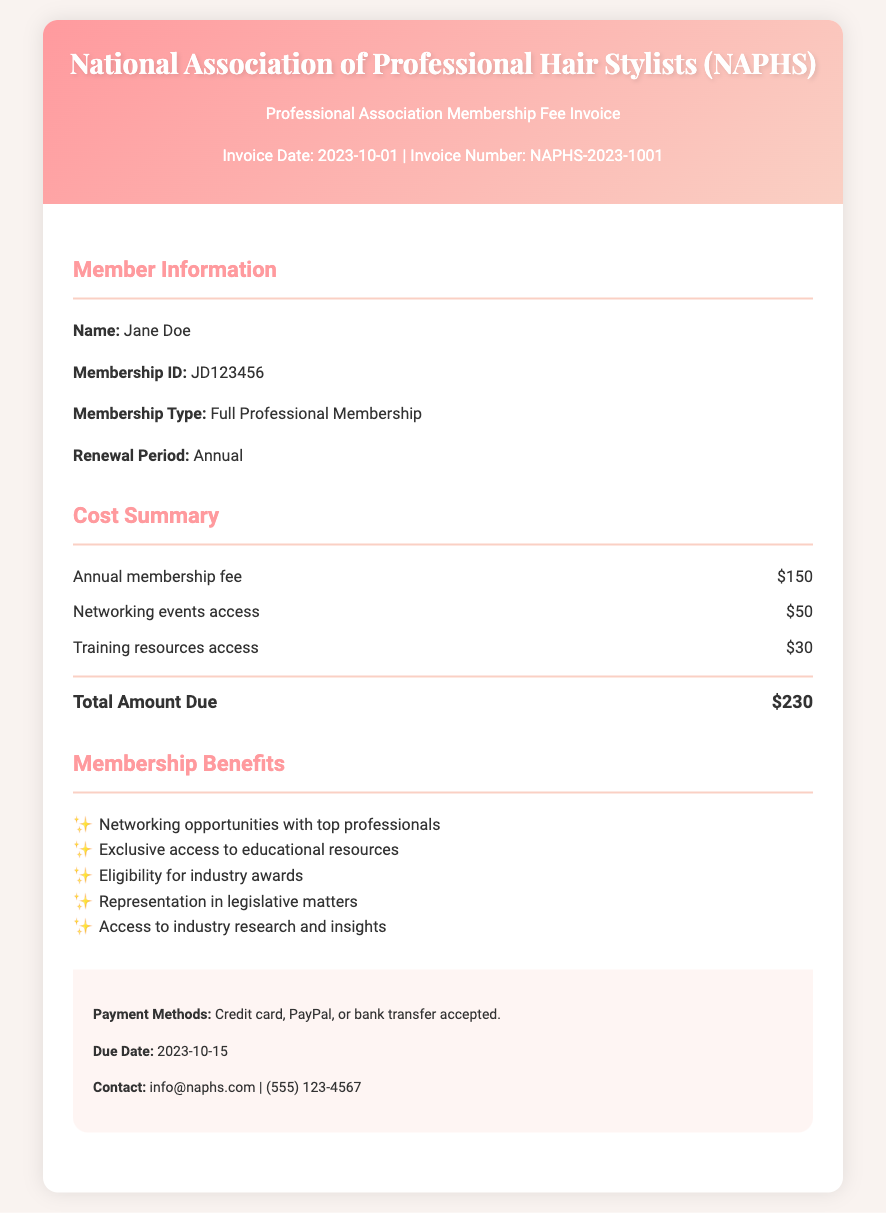What is the name of the membership organization? The document specifies that the membership organization is the National Association of Professional Hair Stylists (NAPHS).
Answer: National Association of Professional Hair Stylists (NAPHS) What is the membership ID of the member? The membership ID is a unique identifier provided in the document for the member, which is JD123456.
Answer: JD123456 What is the total amount due for the membership? The total amount due is calculated from the cost items listed in the cost summary, amounting to $230.
Answer: $230 What is the due date for payment? The due date for the payment is specified in the footer section of the document, which is 2023-10-15.
Answer: 2023-10-15 How much does access to networking events cost? The document lists the cost for networking events access separately, which is $50.
Answer: $50 What are the membership benefits mentioned? Membership benefits are listed in the document, which includes networking opportunities, educational resources, and industry awards eligibility.
Answer: Networking opportunities with top professionals, exclusive access to educational resources, eligibility for industry awards, representation in legislative matters, access to industry research and insights What is the membership type of the member? The document specifies that the membership type for the listed member is Full Professional Membership.
Answer: Full Professional Membership How much does training resources access cost? The cost of accessing training resources is outlined in the cost summary, which is $30.
Answer: $30 What payment methods are accepted? The footer section of the document lists the accepted payment methods for the invoice, which are credit card, PayPal, or bank transfer.
Answer: Credit card, PayPal, or bank transfer 